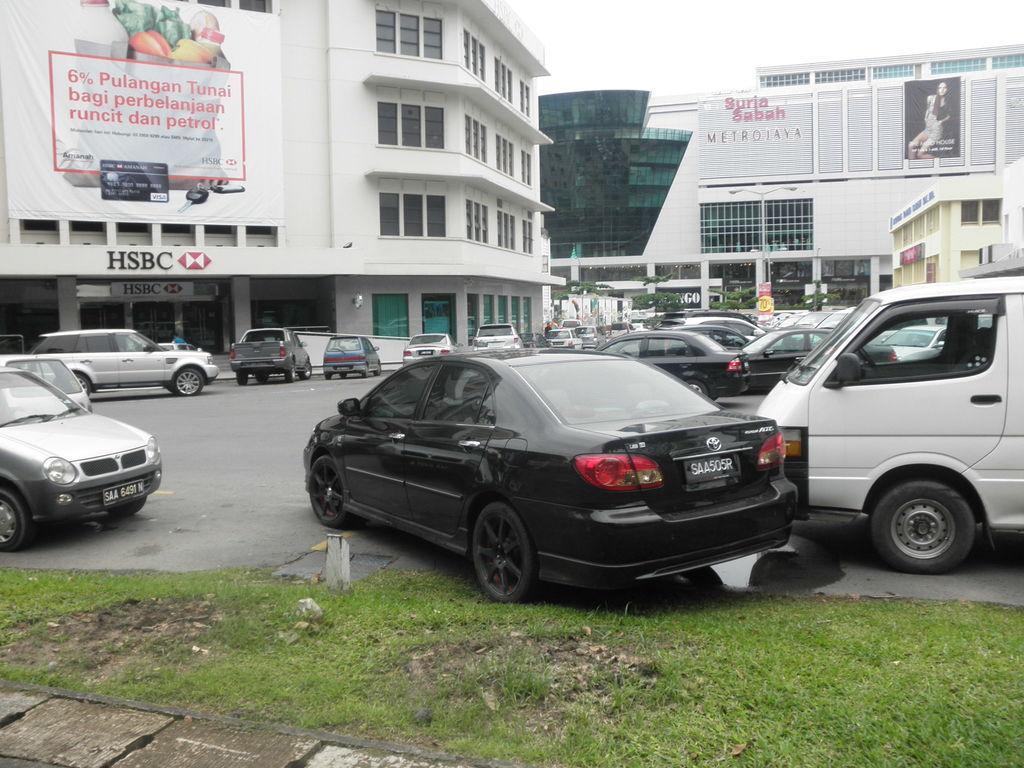In one or two sentences, can you explain what this image depicts? In this image in the front there's grass on the ground. In the center of there are vehicles on the road. In the background there are buildings and on the buildings there are boards with some text written on it. 